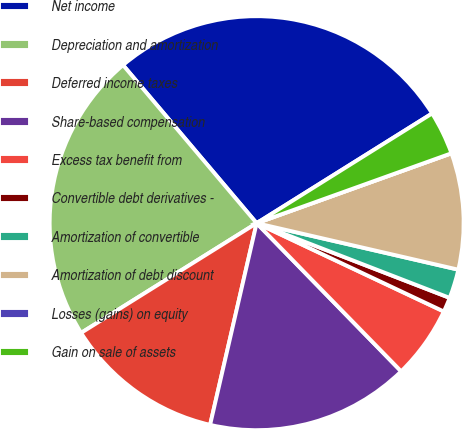Convert chart to OTSL. <chart><loc_0><loc_0><loc_500><loc_500><pie_chart><fcel>Net income<fcel>Depreciation and amortization<fcel>Deferred income taxes<fcel>Share-based compensation<fcel>Excess tax benefit from<fcel>Convertible debt derivatives -<fcel>Amortization of convertible<fcel>Amortization of debt discount<fcel>Losses (gains) on equity<fcel>Gain on sale of assets<nl><fcel>27.27%<fcel>22.72%<fcel>12.5%<fcel>15.91%<fcel>5.68%<fcel>1.14%<fcel>2.27%<fcel>9.09%<fcel>0.0%<fcel>3.41%<nl></chart> 